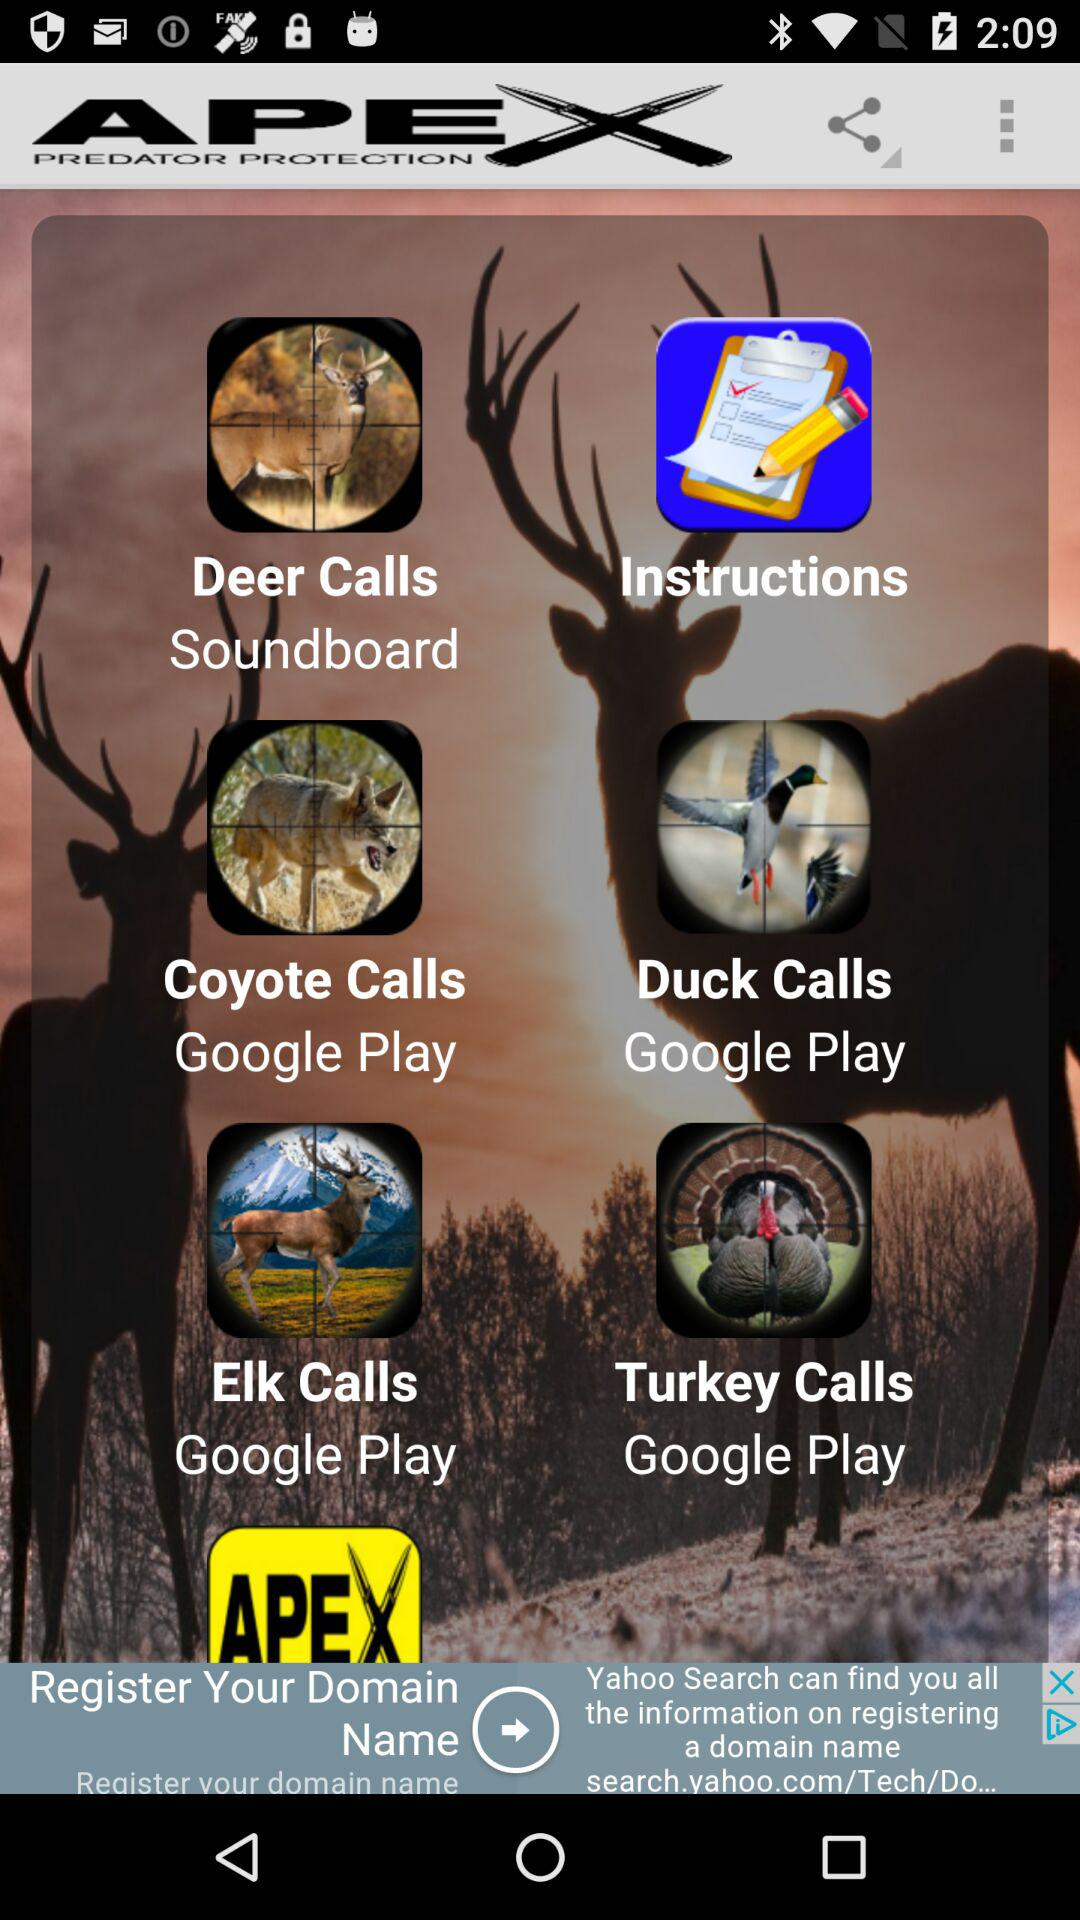What are the names of the different types of calls? The names are "Deer Calls", "Coyote Calls", "Elk Calls", "Duck Calls", and "Turkey Calls". 